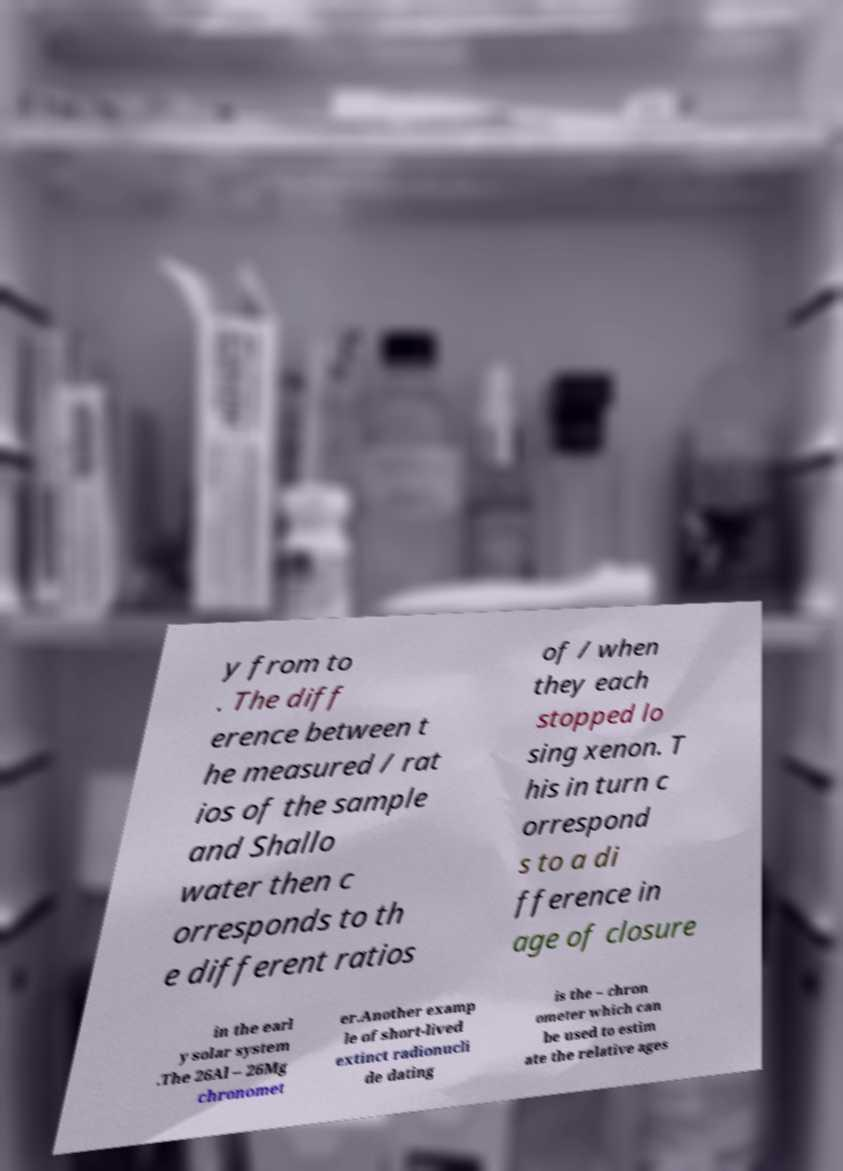For documentation purposes, I need the text within this image transcribed. Could you provide that? y from to . The diff erence between t he measured / rat ios of the sample and Shallo water then c orresponds to th e different ratios of / when they each stopped lo sing xenon. T his in turn c orrespond s to a di fference in age of closure in the earl y solar system .The 26Al – 26Mg chronomet er.Another examp le of short-lived extinct radionucli de dating is the – chron ometer which can be used to estim ate the relative ages 